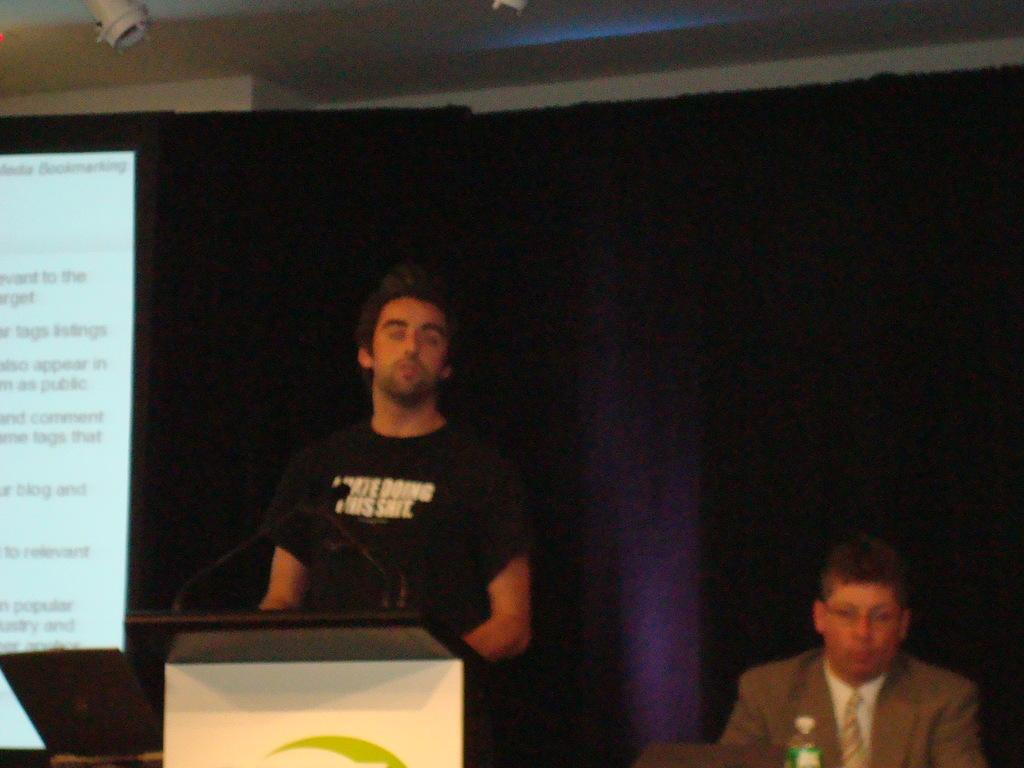How many people are in the image? There are two men in the image. What is one of the men doing in the image? One of the men is standing in front of a podium. What can be seen on the left side of the image? There is a screen present on the left side of the image. What is visible in the background of the image? There is a curtain visible in the background of the image. Is there a stranger in the image? No, there is no stranger in the image. --- Facts: 1. There is a car in the image. 2. The car is red. 3. There are people standing near the car. 4. The car has four wheels. Absurd Topics: unicorn, rainbow, magic Conversation: What is the main subject in the image? The main subject in the image is a car. What color is the car? The car is red. Are there any people in the image? Yes, there are people standing near the car. How many wheels does the car have? The car has four wheels. Reasoning: Let's think step by step in order to produce the conversation. We start by identifying the main subject of the image, which is the car. Next, we describe specific features of the car, such as its color (red) and the number of wheels it has (four wheels)). Then, we observe the actions of the people in the image, noting that they are standing near the car. Absurd Question/Answer: Can you see a unicorn in the image? No, there is no unicorn present in the image. 